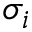Convert formula to latex. <formula><loc_0><loc_0><loc_500><loc_500>\sigma _ { i }</formula> 